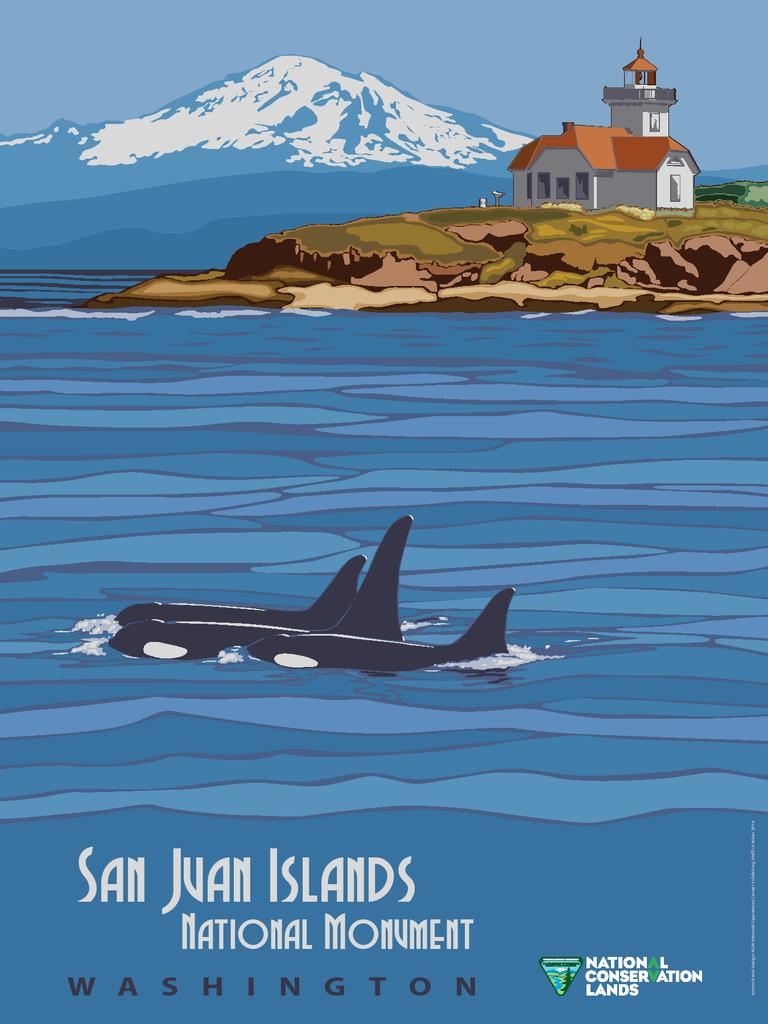Provide a one-sentence caption for the provided image. a poster that has National Conservation Lands written in the corner. 